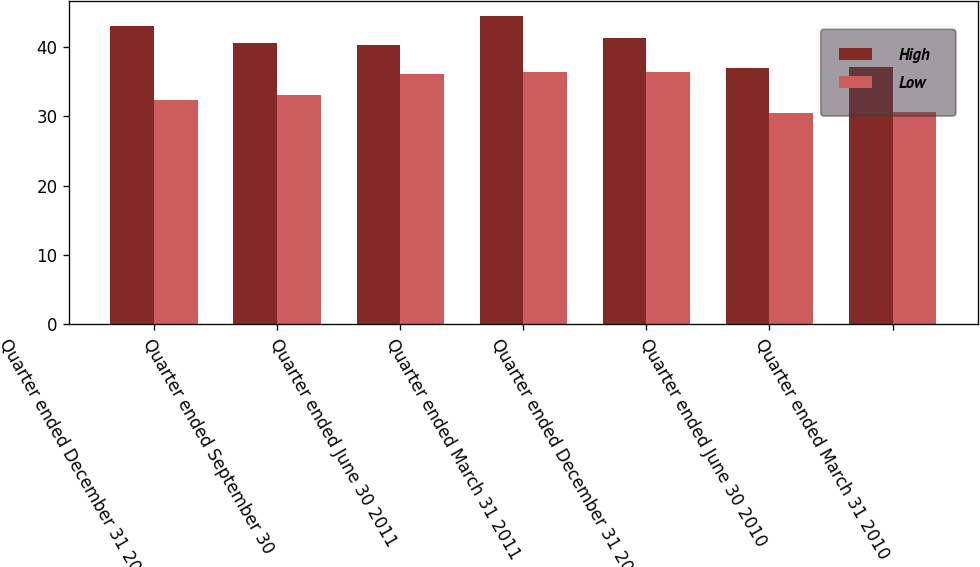<chart> <loc_0><loc_0><loc_500><loc_500><stacked_bar_chart><ecel><fcel>Quarter ended December 31 2011<fcel>Quarter ended September 30<fcel>Quarter ended June 30 2011<fcel>Quarter ended March 31 2011<fcel>Quarter ended December 31 2010<fcel>Quarter ended June 30 2010<fcel>Quarter ended March 31 2010<nl><fcel>High<fcel>43.12<fcel>40.6<fcel>40.35<fcel>44.44<fcel>41.29<fcel>37.03<fcel>37.12<nl><fcel>Low<fcel>32.36<fcel>33.06<fcel>36.1<fcel>36.36<fcel>36.38<fcel>30.47<fcel>30.64<nl></chart> 